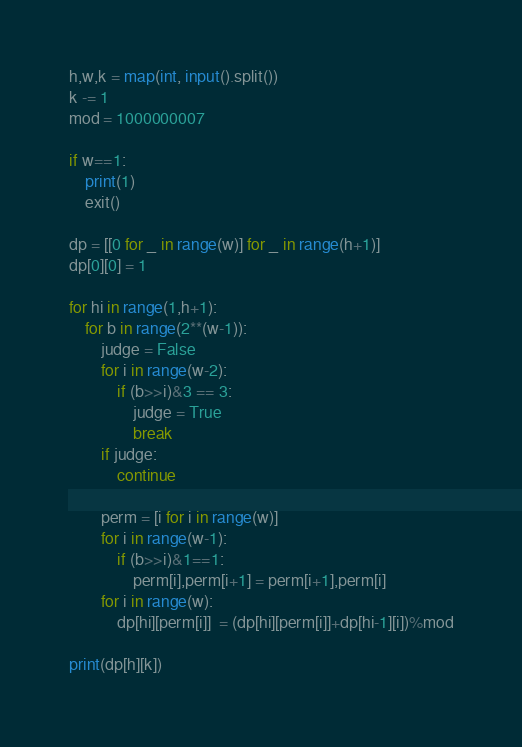Convert code to text. <code><loc_0><loc_0><loc_500><loc_500><_Python_>h,w,k = map(int, input().split())
k -= 1
mod = 1000000007
 
if w==1:
    print(1)
    exit()
 
dp = [[0 for _ in range(w)] for _ in range(h+1)]
dp[0][0] = 1
 
for hi in range(1,h+1):
    for b in range(2**(w-1)):
        judge = False
        for i in range(w-2):
            if (b>>i)&3 == 3:
                judge = True
                break
        if judge:
            continue
 
        perm = [i for i in range(w)]
        for i in range(w-1):
            if (b>>i)&1==1:
                perm[i],perm[i+1] = perm[i+1],perm[i]
        for i in range(w):
            dp[hi][perm[i]]  = (dp[hi][perm[i]]+dp[hi-1][i])%mod
 
print(dp[h][k])</code> 